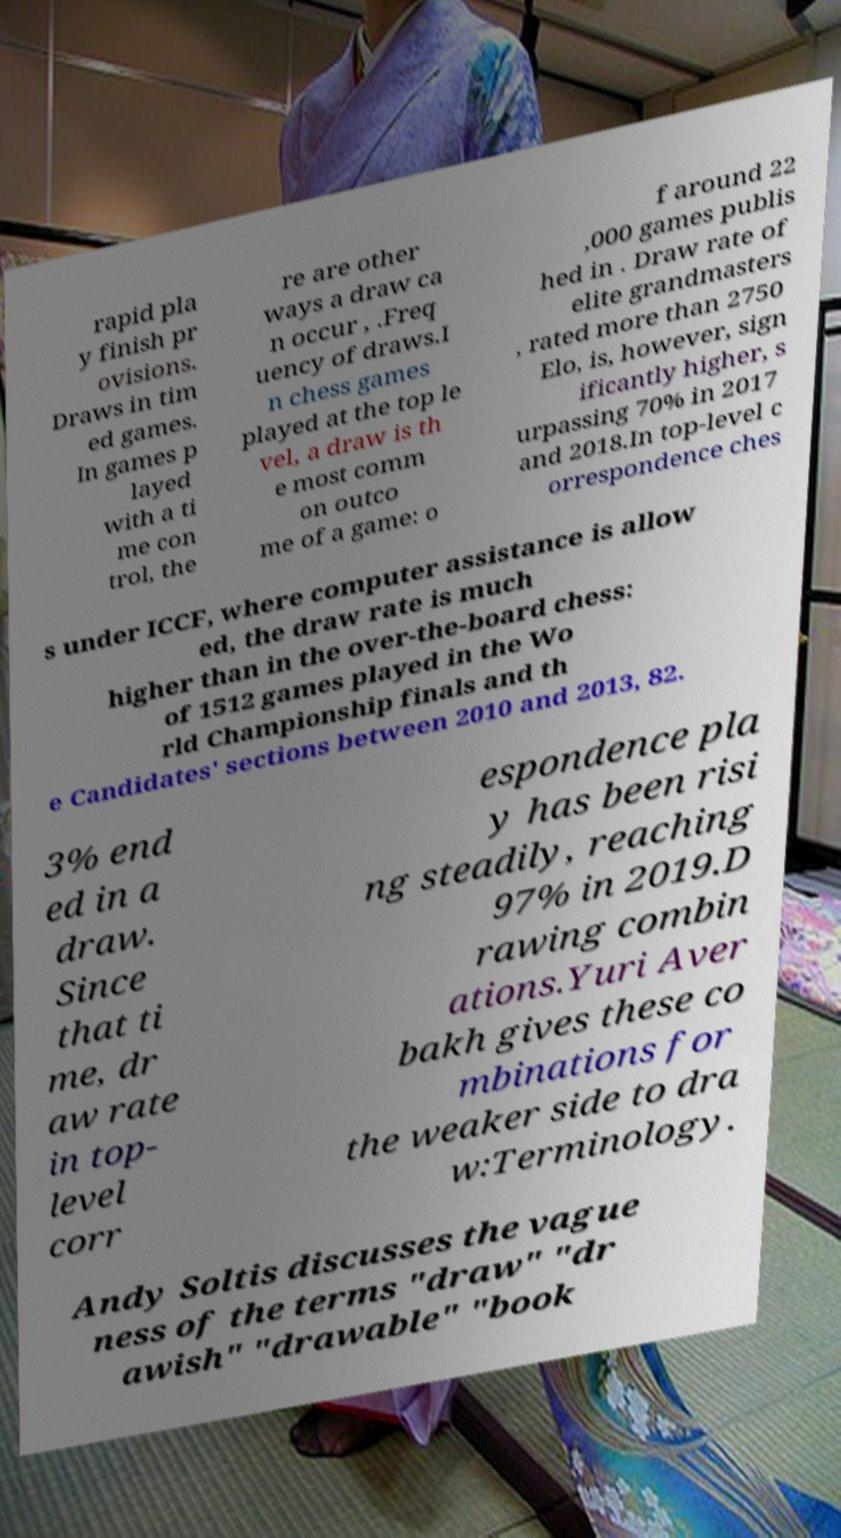Please read and relay the text visible in this image. What does it say? rapid pla y finish pr ovisions. Draws in tim ed games. In games p layed with a ti me con trol, the re are other ways a draw ca n occur , .Freq uency of draws.I n chess games played at the top le vel, a draw is th e most comm on outco me of a game: o f around 22 ,000 games publis hed in . Draw rate of elite grandmasters , rated more than 2750 Elo, is, however, sign ificantly higher, s urpassing 70% in 2017 and 2018.In top-level c orrespondence ches s under ICCF, where computer assistance is allow ed, the draw rate is much higher than in the over-the-board chess: of 1512 games played in the Wo rld Championship finals and th e Candidates' sections between 2010 and 2013, 82. 3% end ed in a draw. Since that ti me, dr aw rate in top- level corr espondence pla y has been risi ng steadily, reaching 97% in 2019.D rawing combin ations.Yuri Aver bakh gives these co mbinations for the weaker side to dra w:Terminology. Andy Soltis discusses the vague ness of the terms "draw" "dr awish" "drawable" "book 